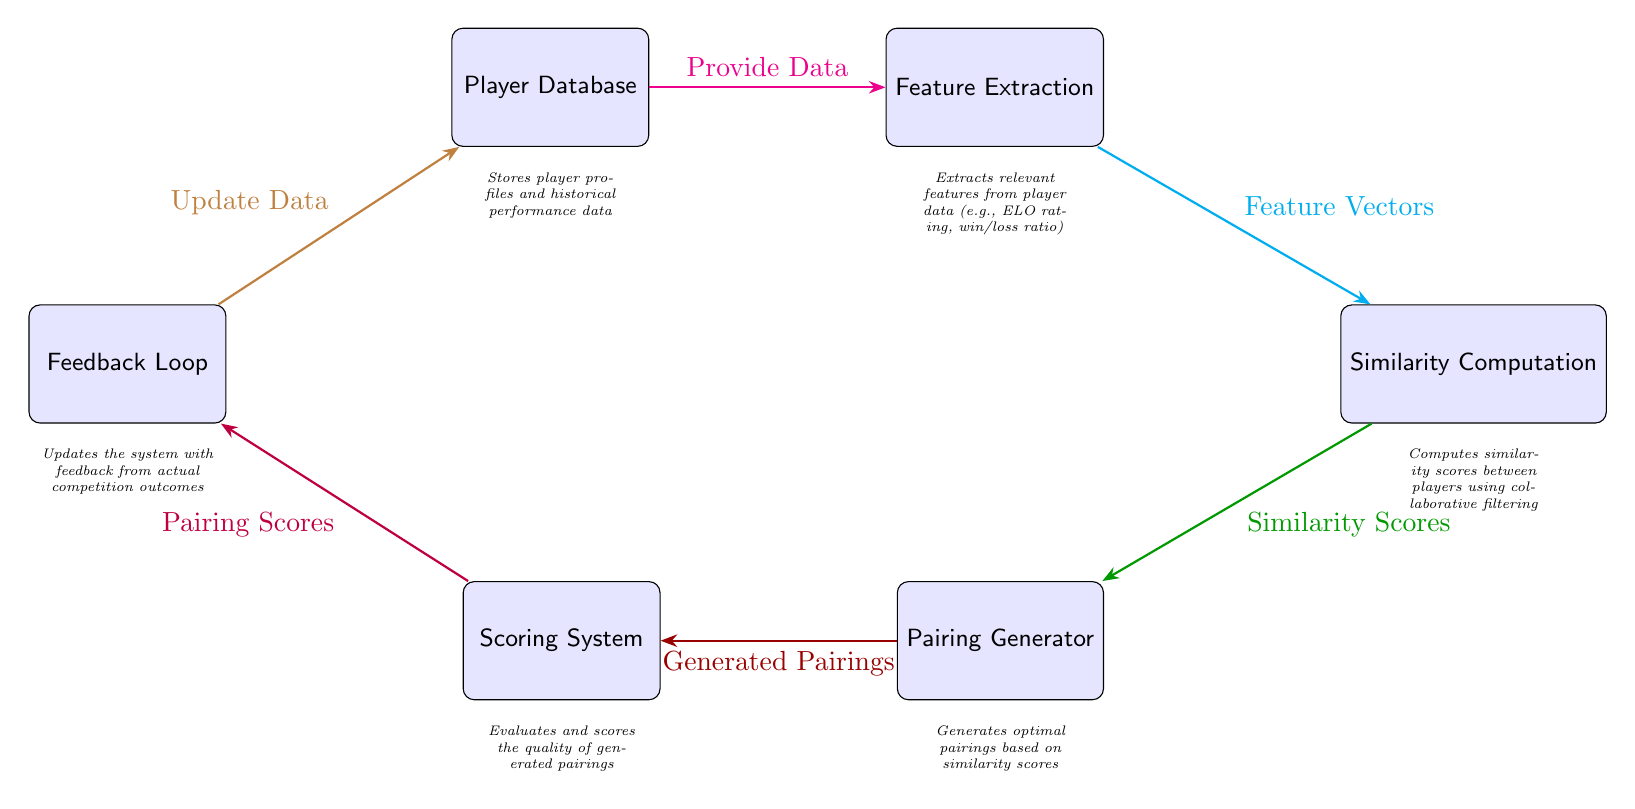What is the first node in the diagram? The first node is labeled "Player Database". It is the initial entry point for data in the diagram.
Answer: Player Database How many nodes are present in the diagram? By counting the labeled boxes in the diagram, we see there are six nodes in total.
Answer: 6 What does the arrow from "Player Database" to "Feature Extraction" represent? The arrow indicates the flow of data, specifically stating "Provide Data", which signifies that data is being sent from the Player Database to Feature Extraction.
Answer: Provide Data What type of data does the "Feature Extraction" node generate? The "Feature Extraction" node outputs "Feature Vectors", which are essential for the next steps of the process.
Answer: Feature Vectors Which node is responsible for producing similarity scores? The "Similarity Computation" node computes similarity scores between players based on the feature vectors provided to it.
Answer: Similarity Computation What is the relationship between "Pairing Generator" and "Scoring System"? The "Pairing Generator" node sends "Generated Pairings" to the "Scoring System", indicating the output of the generator is evaluated by the scoring system.
Answer: Generated Pairings What kind of feedback is incorporated into the system? The "Feedback Loop" node indicates that feedback from actual competition outcomes is used to "Update Data" in the Player Database, effectively refining the data model.
Answer: Update Data Which node follows "Scoring System" in the flow of the diagram? The "Feedback Loop" node follows the "Scoring System" as it utilizes the scoring results to provide feedback to update the player data.
Answer: Feedback Loop What is the primary function of the "Pairing Generator"? The primary function of the "Pairing Generator" is to generate optimal pairings based on the similarity scores it receives from the "Similarity Computation" node.
Answer: Generate optimal pairings 